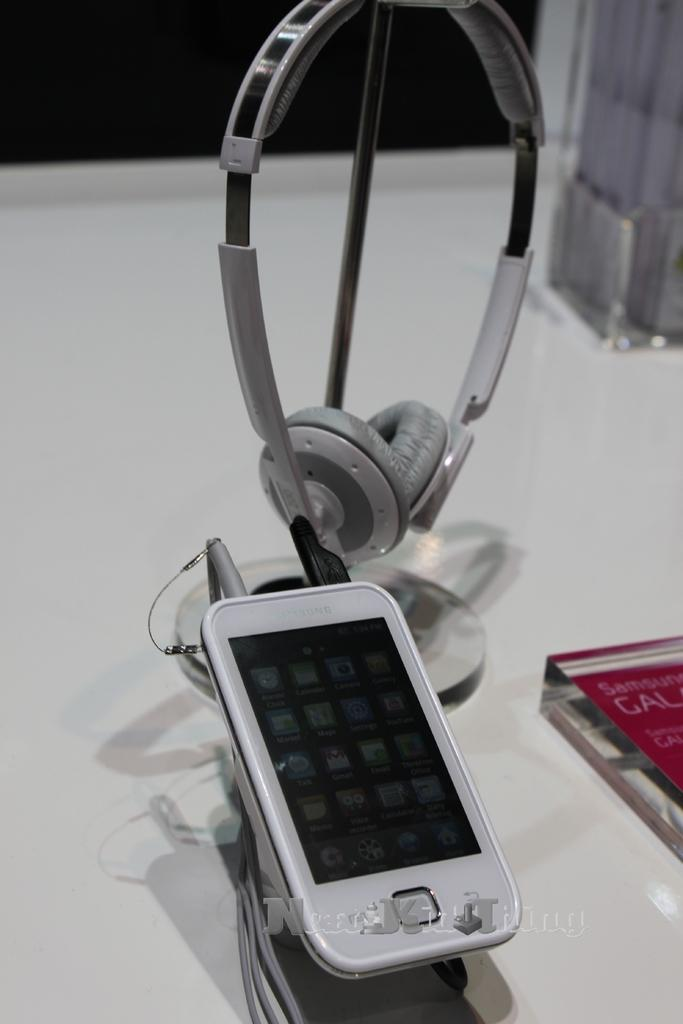What device is the person holding in the image? The person is holding a skateboard in the image. What protective gear is the person wearing? The person is wearing a helmet in the image. What can be seen in the background of the image? There is a skate park and some people in the background of the image. How many babies are being forced to play with the skateboard in the image? There are no babies present in the image, and no one is being forced to play with the skateboard. 